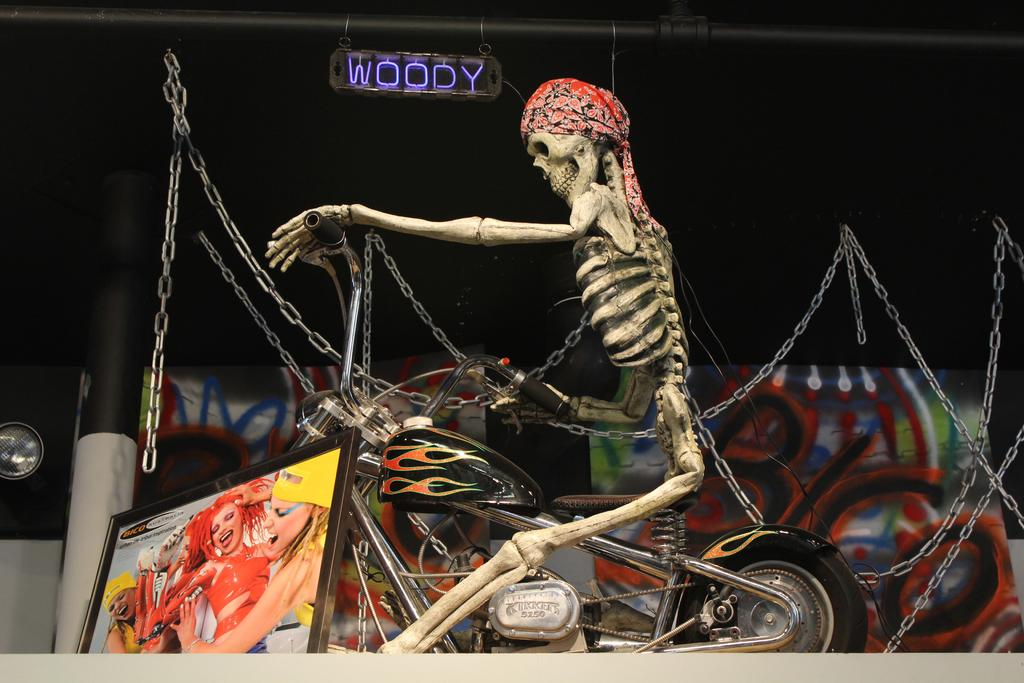What is the main subject of the image? The main subject of the image is a human skeleton. What is the skeleton doing in the image? The skeleton is on a bike in the image. What can be seen on the left side of the image? There is a photo frame on the left side of the image. What is visible at the top of the image? The name with lights is visible at the top of the image. What type of underwear is the skeleton wearing in the image? The image does not show the skeleton wearing any underwear, as it is a skeleton and does not have any flesh or clothing. 